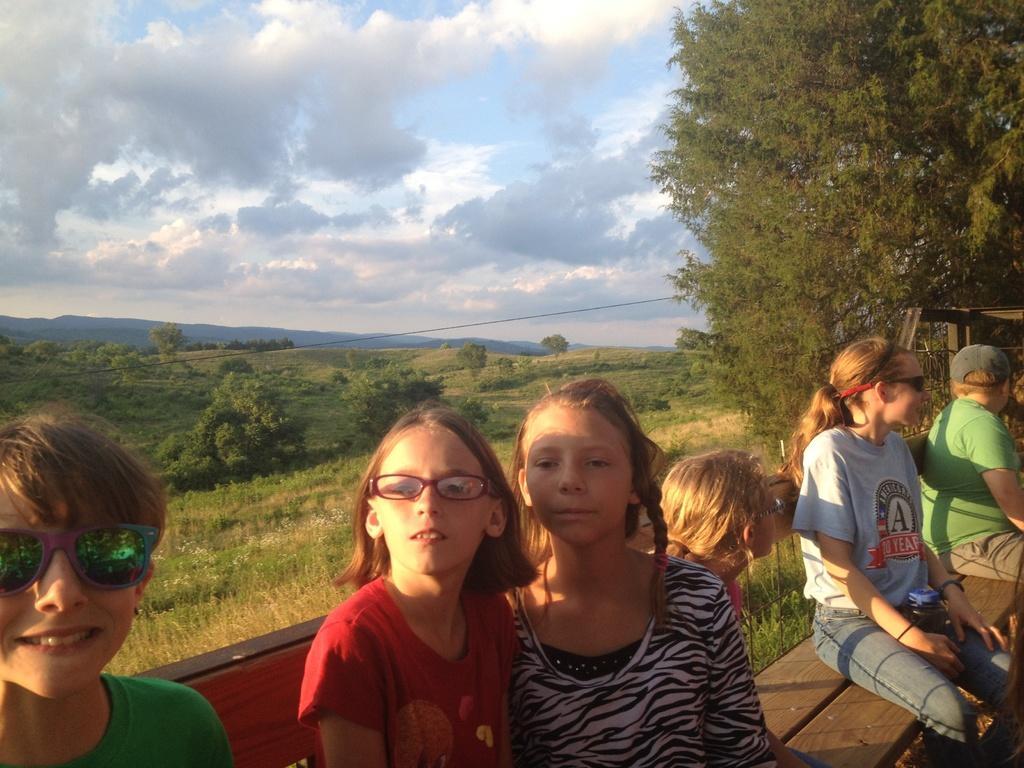Describe this image in one or two sentences. In this image I can see few children are sitting in the front. In the centre I can see a girl is wearing a specs and on the both sides of the image I can see two of them are wearing shades. On the right side I can see one of them is wearing a cap. In the background I can see an open grass ground, number of trees, clouds and the sky. 